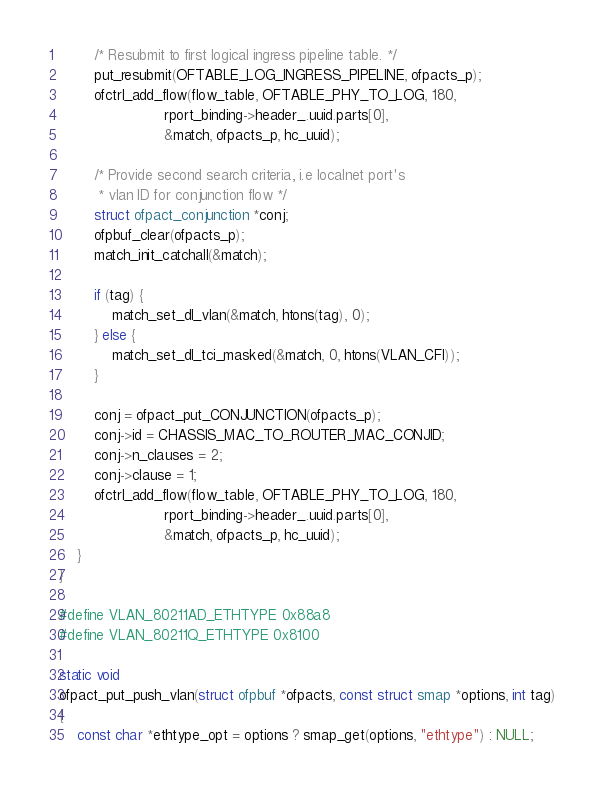<code> <loc_0><loc_0><loc_500><loc_500><_C_>        /* Resubmit to first logical ingress pipeline table. */
        put_resubmit(OFTABLE_LOG_INGRESS_PIPELINE, ofpacts_p);
        ofctrl_add_flow(flow_table, OFTABLE_PHY_TO_LOG, 180,
                        rport_binding->header_.uuid.parts[0],
                        &match, ofpacts_p, hc_uuid);

        /* Provide second search criteria, i.e localnet port's
         * vlan ID for conjunction flow */
        struct ofpact_conjunction *conj;
        ofpbuf_clear(ofpacts_p);
        match_init_catchall(&match);

        if (tag) {
            match_set_dl_vlan(&match, htons(tag), 0);
        } else {
            match_set_dl_tci_masked(&match, 0, htons(VLAN_CFI));
        }

        conj = ofpact_put_CONJUNCTION(ofpacts_p);
        conj->id = CHASSIS_MAC_TO_ROUTER_MAC_CONJID;
        conj->n_clauses = 2;
        conj->clause = 1;
        ofctrl_add_flow(flow_table, OFTABLE_PHY_TO_LOG, 180,
                        rport_binding->header_.uuid.parts[0],
                        &match, ofpacts_p, hc_uuid);
    }
}

#define VLAN_80211AD_ETHTYPE 0x88a8
#define VLAN_80211Q_ETHTYPE 0x8100

static void
ofpact_put_push_vlan(struct ofpbuf *ofpacts, const struct smap *options, int tag)
{
    const char *ethtype_opt = options ? smap_get(options, "ethtype") : NULL;
</code> 